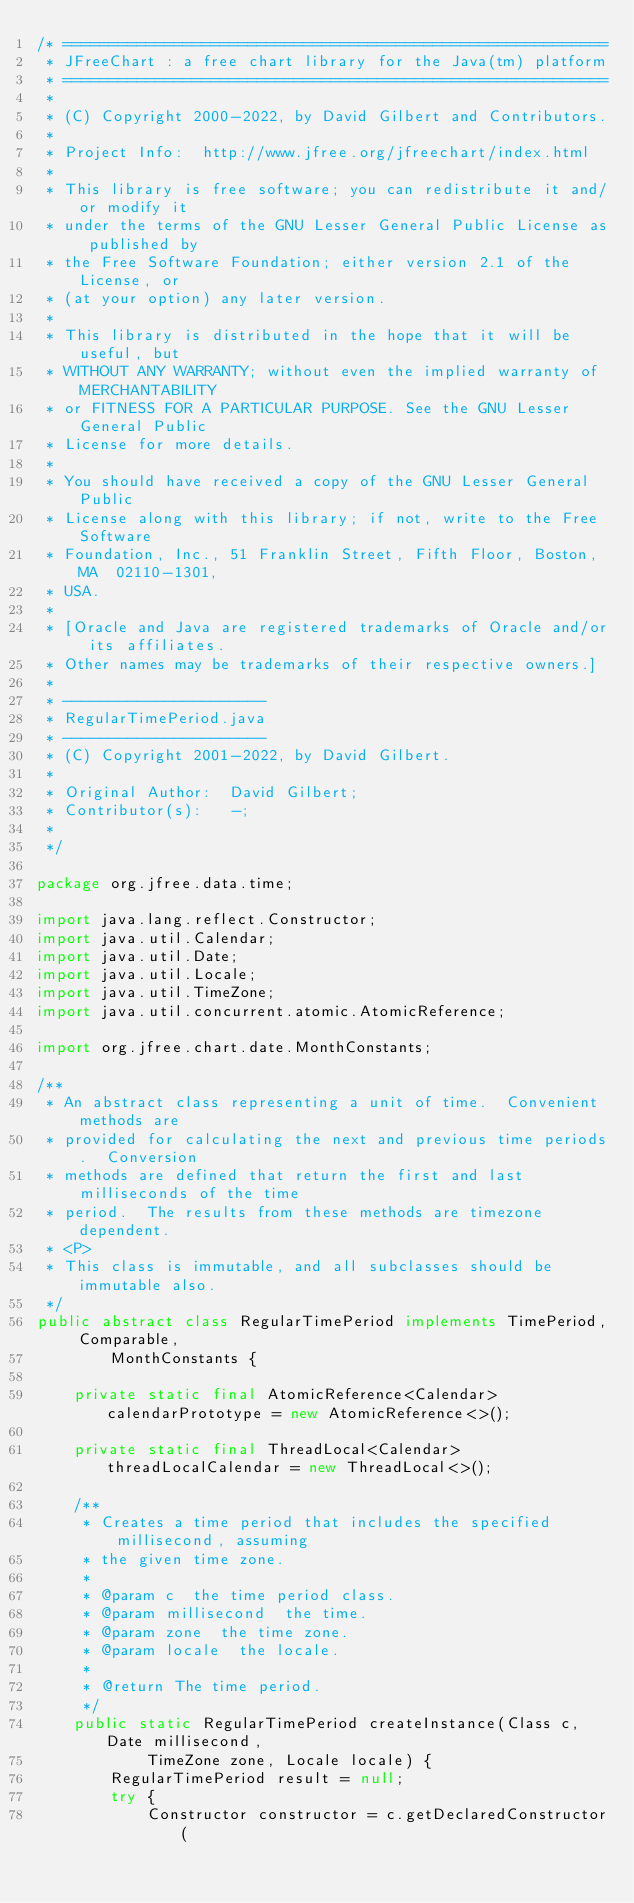<code> <loc_0><loc_0><loc_500><loc_500><_Java_>/* ===========================================================
 * JFreeChart : a free chart library for the Java(tm) platform
 * ===========================================================
 *
 * (C) Copyright 2000-2022, by David Gilbert and Contributors.
 *
 * Project Info:  http://www.jfree.org/jfreechart/index.html
 *
 * This library is free software; you can redistribute it and/or modify it
 * under the terms of the GNU Lesser General Public License as published by
 * the Free Software Foundation; either version 2.1 of the License, or
 * (at your option) any later version.
 *
 * This library is distributed in the hope that it will be useful, but
 * WITHOUT ANY WARRANTY; without even the implied warranty of MERCHANTABILITY
 * or FITNESS FOR A PARTICULAR PURPOSE. See the GNU Lesser General Public
 * License for more details.
 *
 * You should have received a copy of the GNU Lesser General Public
 * License along with this library; if not, write to the Free Software
 * Foundation, Inc., 51 Franklin Street, Fifth Floor, Boston, MA  02110-1301,
 * USA.
 *
 * [Oracle and Java are registered trademarks of Oracle and/or its affiliates. 
 * Other names may be trademarks of their respective owners.]
 *
 * ----------------------
 * RegularTimePeriod.java
 * ----------------------
 * (C) Copyright 2001-2022, by David Gilbert.
 *
 * Original Author:  David Gilbert;
 * Contributor(s):   -;
 * 
 */

package org.jfree.data.time;

import java.lang.reflect.Constructor;
import java.util.Calendar;
import java.util.Date;
import java.util.Locale;
import java.util.TimeZone;
import java.util.concurrent.atomic.AtomicReference;

import org.jfree.chart.date.MonthConstants;

/**
 * An abstract class representing a unit of time.  Convenient methods are
 * provided for calculating the next and previous time periods.  Conversion
 * methods are defined that return the first and last milliseconds of the time
 * period.  The results from these methods are timezone dependent.
 * <P>
 * This class is immutable, and all subclasses should be immutable also.
 */
public abstract class RegularTimePeriod implements TimePeriod, Comparable,
        MonthConstants {

    private static final AtomicReference<Calendar> calendarPrototype = new AtomicReference<>();

    private static final ThreadLocal<Calendar> threadLocalCalendar = new ThreadLocal<>();

    /**
     * Creates a time period that includes the specified millisecond, assuming
     * the given time zone.
     *
     * @param c  the time period class.
     * @param millisecond  the time.
     * @param zone  the time zone.
     * @param locale  the locale.
     *
     * @return The time period.
     */
    public static RegularTimePeriod createInstance(Class c, Date millisecond,
            TimeZone zone, Locale locale) {
        RegularTimePeriod result = null;
        try {
            Constructor constructor = c.getDeclaredConstructor(</code> 